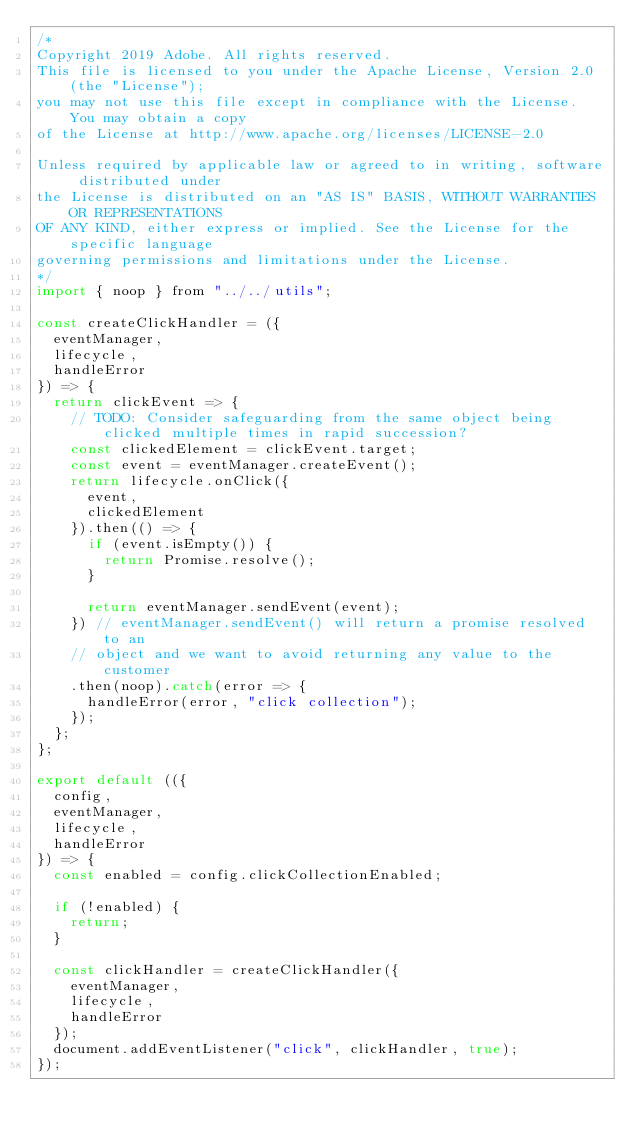<code> <loc_0><loc_0><loc_500><loc_500><_JavaScript_>/*
Copyright 2019 Adobe. All rights reserved.
This file is licensed to you under the Apache License, Version 2.0 (the "License");
you may not use this file except in compliance with the License. You may obtain a copy
of the License at http://www.apache.org/licenses/LICENSE-2.0

Unless required by applicable law or agreed to in writing, software distributed under
the License is distributed on an "AS IS" BASIS, WITHOUT WARRANTIES OR REPRESENTATIONS
OF ANY KIND, either express or implied. See the License for the specific language
governing permissions and limitations under the License.
*/
import { noop } from "../../utils";

const createClickHandler = ({
  eventManager,
  lifecycle,
  handleError
}) => {
  return clickEvent => {
    // TODO: Consider safeguarding from the same object being clicked multiple times in rapid succession?
    const clickedElement = clickEvent.target;
    const event = eventManager.createEvent();
    return lifecycle.onClick({
      event,
      clickedElement
    }).then(() => {
      if (event.isEmpty()) {
        return Promise.resolve();
      }

      return eventManager.sendEvent(event);
    }) // eventManager.sendEvent() will return a promise resolved to an
    // object and we want to avoid returning any value to the customer
    .then(noop).catch(error => {
      handleError(error, "click collection");
    });
  };
};

export default (({
  config,
  eventManager,
  lifecycle,
  handleError
}) => {
  const enabled = config.clickCollectionEnabled;

  if (!enabled) {
    return;
  }

  const clickHandler = createClickHandler({
    eventManager,
    lifecycle,
    handleError
  });
  document.addEventListener("click", clickHandler, true);
});</code> 